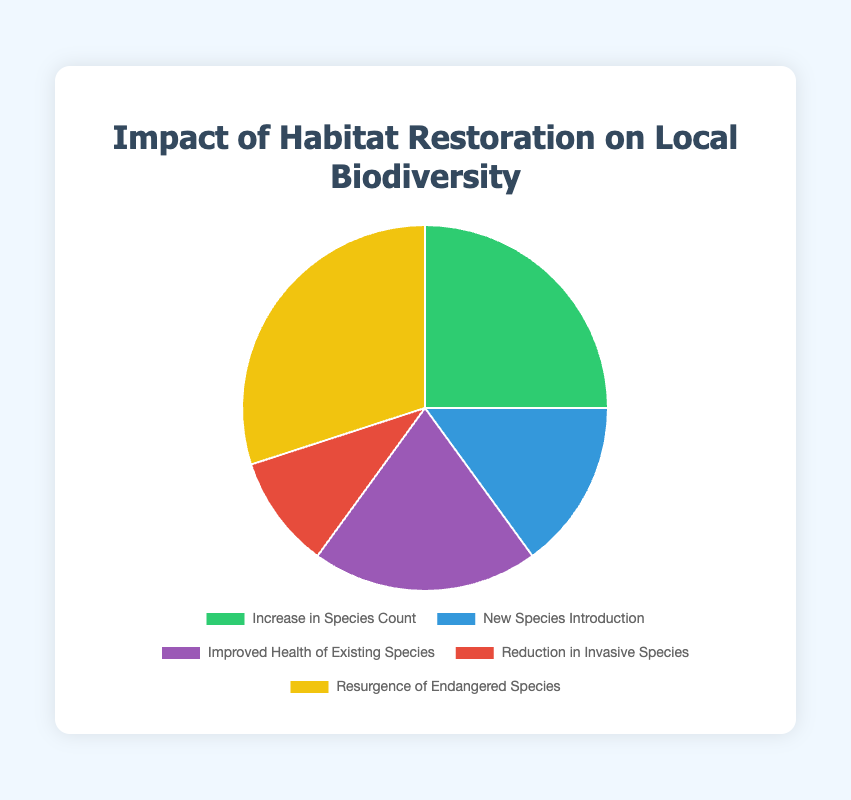What is the largest impact of habitat restoration on local biodiversity? The largest impact is represented by the segment with the highest percentage in the pie chart. The data shows that “Resurgence of Endangered Species” has the highest impact at 30%.
Answer: Resurgence of Endangered Species Which impact has the smallest percentage? By looking at the pie chart and the data labels, the smallest segment represents the “Reduction in Invasive Species” at 10%.
Answer: Reduction in Invasive Species What is the total percentage of "Increase in Species Count" and "New Species Introduction"? Sum the percentages for both impacts: “Increase in Species Count” (25%) and “New Species Introduction” (15%) which gives 25% + 15% = 40%.
Answer: 40% Compare the percentage of "Improved Health of Existing Species" with "New Species Introduction". Which one is higher and by how much? “Improved Health of Existing Species” has a percentage of 20%, while “New Species Introduction” is at 15%. The difference is 20% - 15% = 5%. “Improved Health of Existing Species” is higher by 5%.
Answer: Improved Health of Existing Species, by 5% Sum the percentages of "Reduction in Invasive Species", "New Species Introduction", and "Improved Health of Existing Species". What is the result? Adding the percentages together: “Reduction in Invasive Species” (10%), “New Species Introduction” (15%), and “Improved Health of Existing Species” (20%) gives 10% + 15% + 20% = 45%.
Answer: 45% What color represents "Increase in Species Count" in the chart? The segment representing “Increase in Species Count” is colored green according to the visual description of the chart.
Answer: Green If we combine the percentages of all segments except "Resurgence of Endangered Species," what is the total percentage? Sum the percentages of all other segments: “Increase in Species Count” (25%), “New Species Introduction” (15%), “Improved Health of Existing Species” (20%), and “Reduction in Invasive Species” (10%). This gives 25% + 15% + 20% + 10% = 70%.
Answer: 70% Which two impacts together make up half of the total percentage? We need to identify two segments whose combined percentage equals 50%. “Resurgence of Endangered Species” (30%) and “Increase in Species Count” (25%) together make 30% + 25% = 55%, which is more. “Increase in Species Count” (25%) and “Improved Health of Existing Species” (20%) together make 25% + 20% = 45%, which is less. Finally, “Increase in Species Count” (25%) and “New Species Introduction” (15%) together make 25% + 15% = 40%. Thus, no two impact pairs add up to exactly 50%, but "Increase in Species Count" and "New Species Introduction" come closest.
Answer: None 